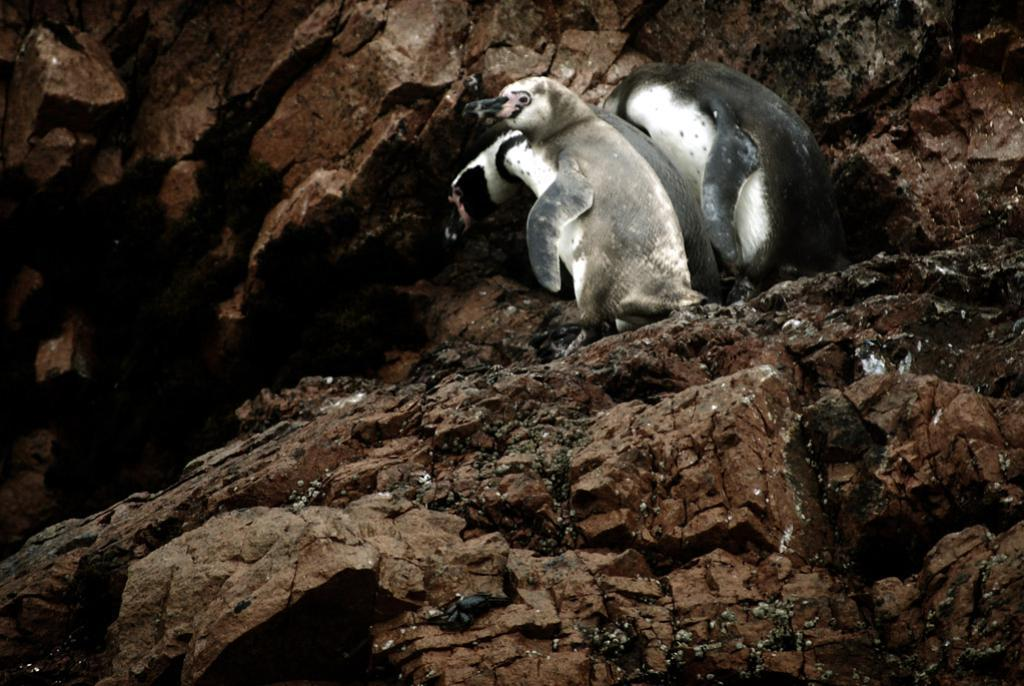What type of animals are present in the image? There are penguins in the image. Where are the penguins located in the image? The penguins are at the top side of the image. What surface are the penguins standing on? The penguins are on rocks. Can you describe the surrounding area in the image? There are rocks around the area in the image. What type of sticks are the penguins using for pleasure in the image? There are no sticks present in the image, and the penguins are not engaging in any activity related to pleasure. 